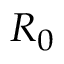<formula> <loc_0><loc_0><loc_500><loc_500>R _ { 0 }</formula> 